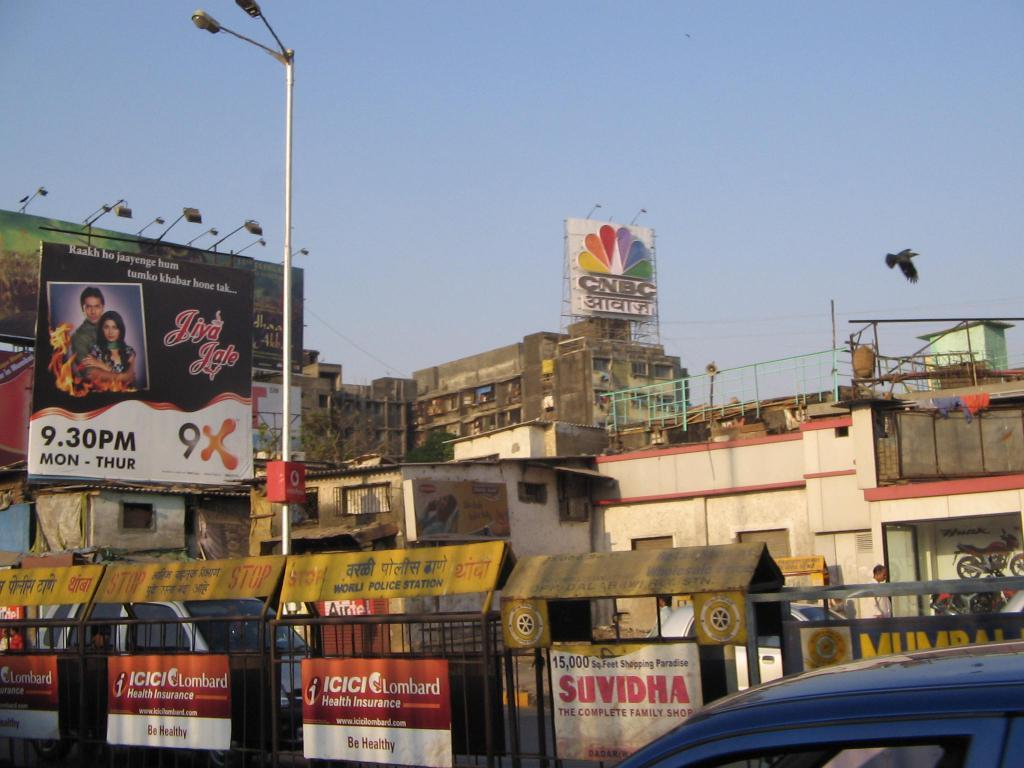<image>
Give a short and clear explanation of the subsequent image. Billboard showing a photo of a couple and red words saying "Tiya Tale". 